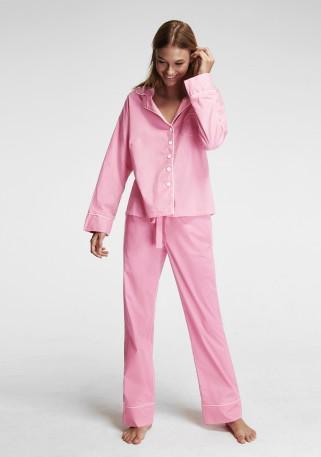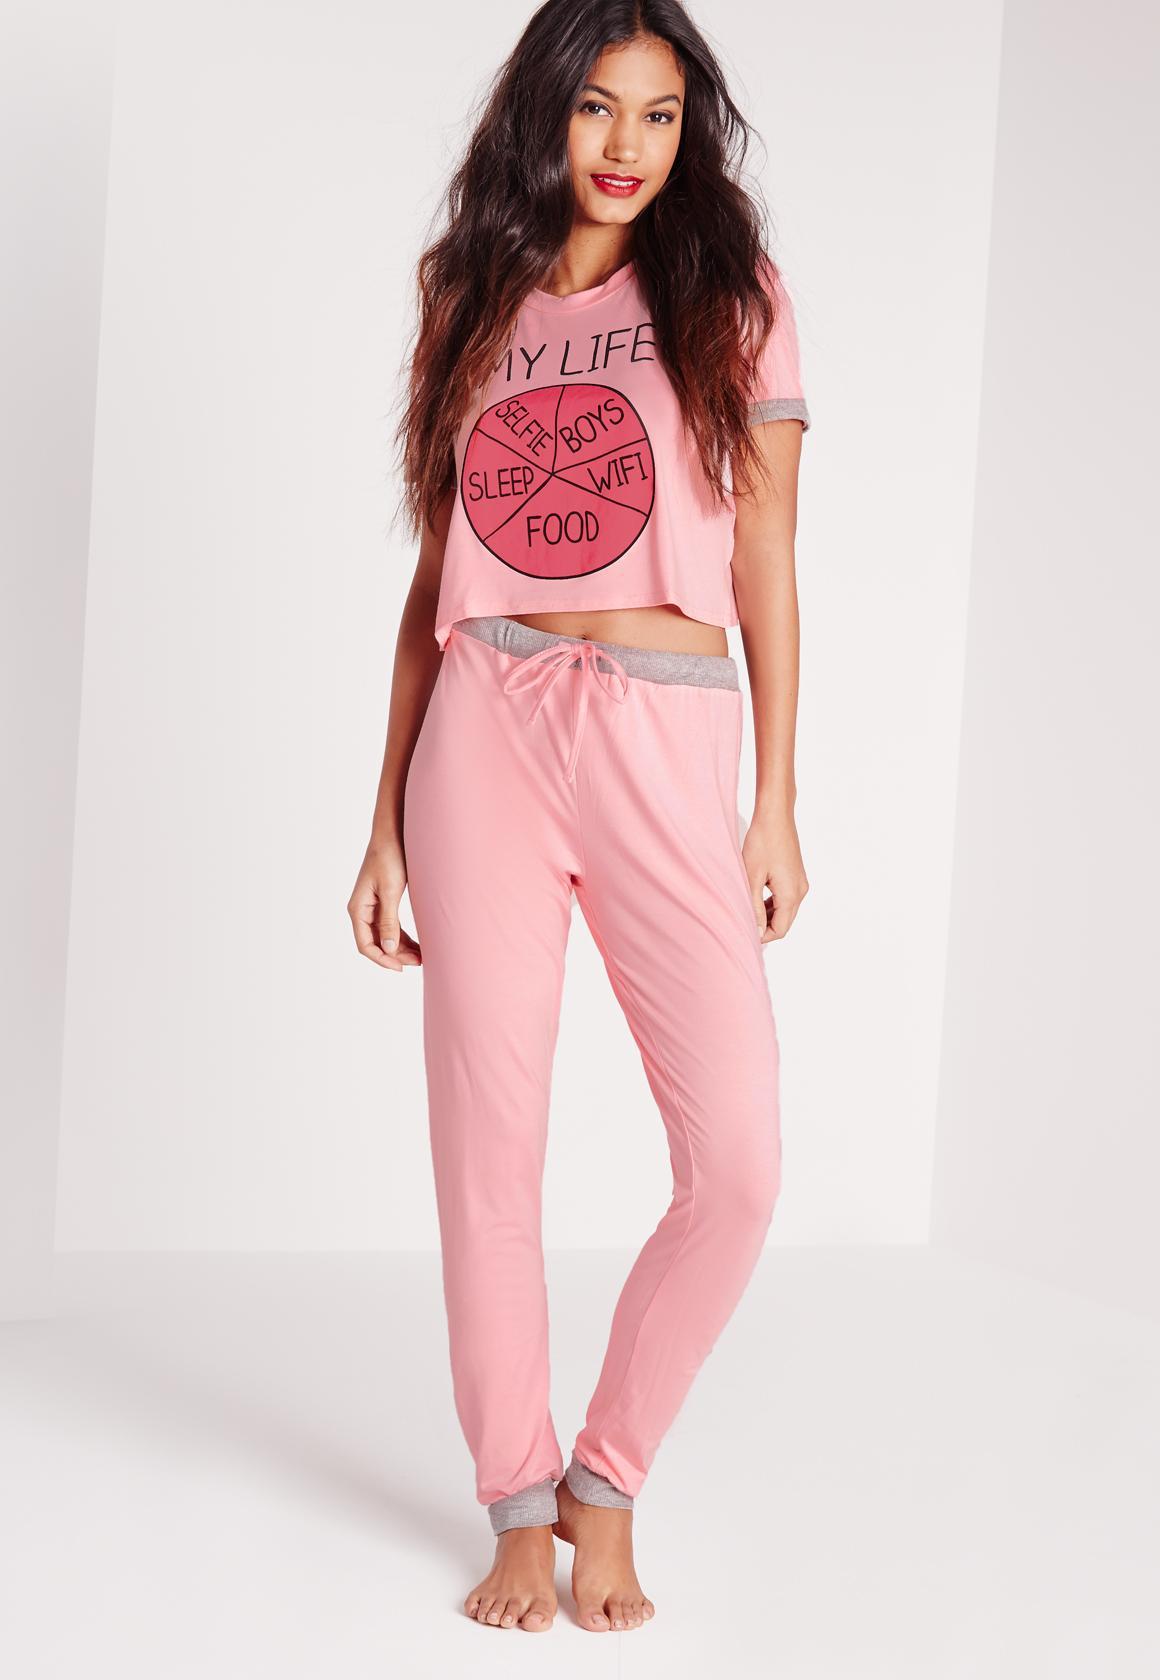The first image is the image on the left, the second image is the image on the right. Analyze the images presented: Is the assertion "Exactly one model wears a long sleeved collared button-up top, and exactly one model wears a short sleeve top, but no model wears short shorts." valid? Answer yes or no. Yes. The first image is the image on the left, the second image is the image on the right. Evaluate the accuracy of this statement regarding the images: "A woman is wearing a pajama with short sleeves in one of the images.". Is it true? Answer yes or no. Yes. 